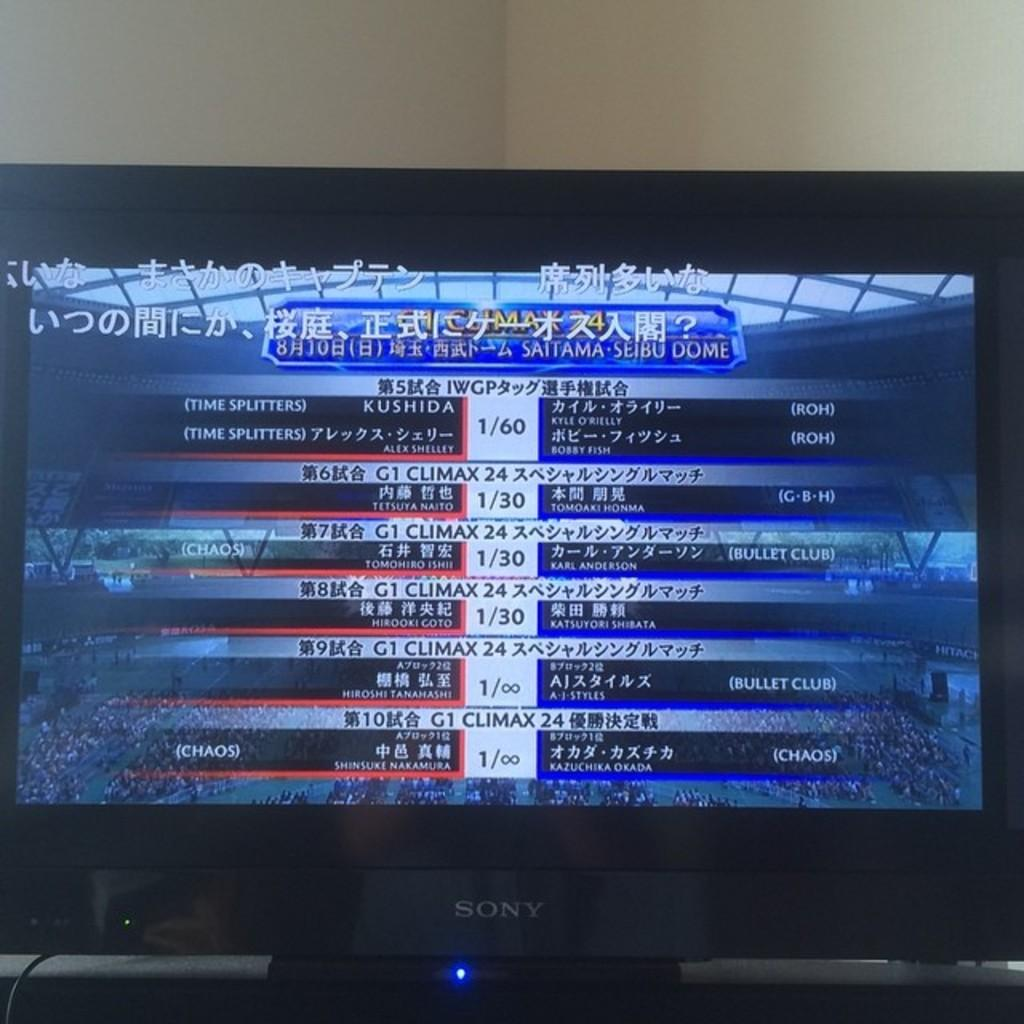<image>
Offer a succinct explanation of the picture presented. television showing sports team's scores names KUSHIDA and Chinese characters. 